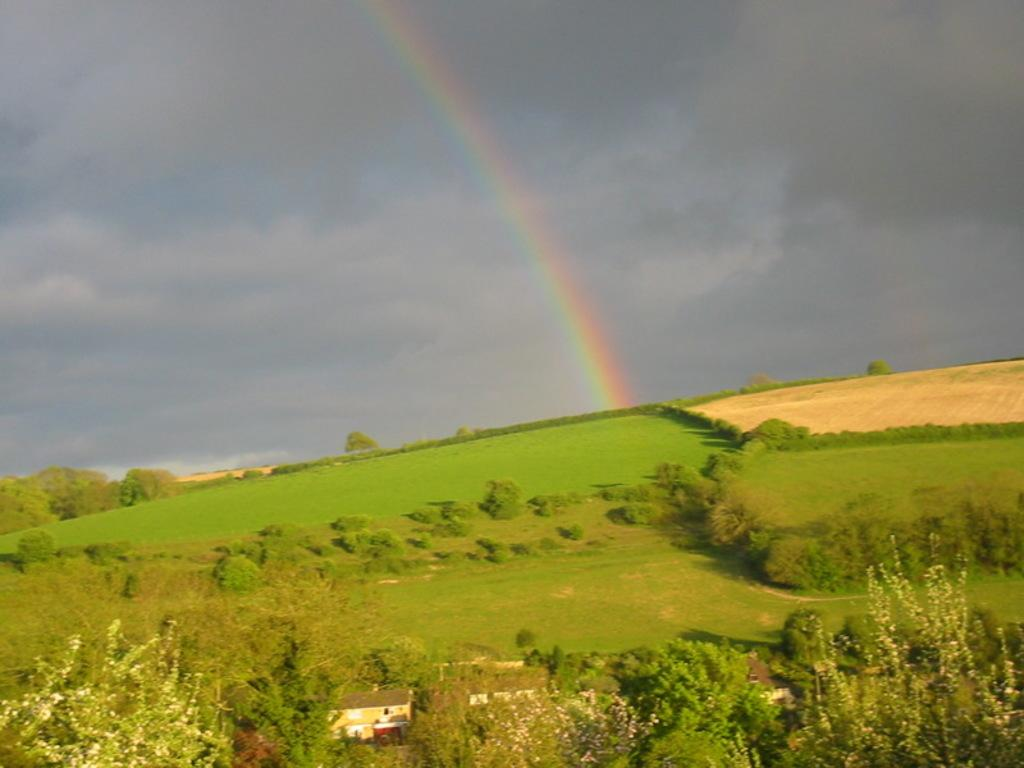What type of vegetation can be seen in the image? There are trees, plants, and grass in the image. What type of structures are visible in the image? There are houses in the image. What else can be found on the ground in the image? There are other objects on the ground in the image. What is visible in the background of the image? The sky is visible in the background of the image, and there is a rainbow present. What type of potato is being used to water the plants in the image? There is no potato present in the image, and plants are not being watered. 